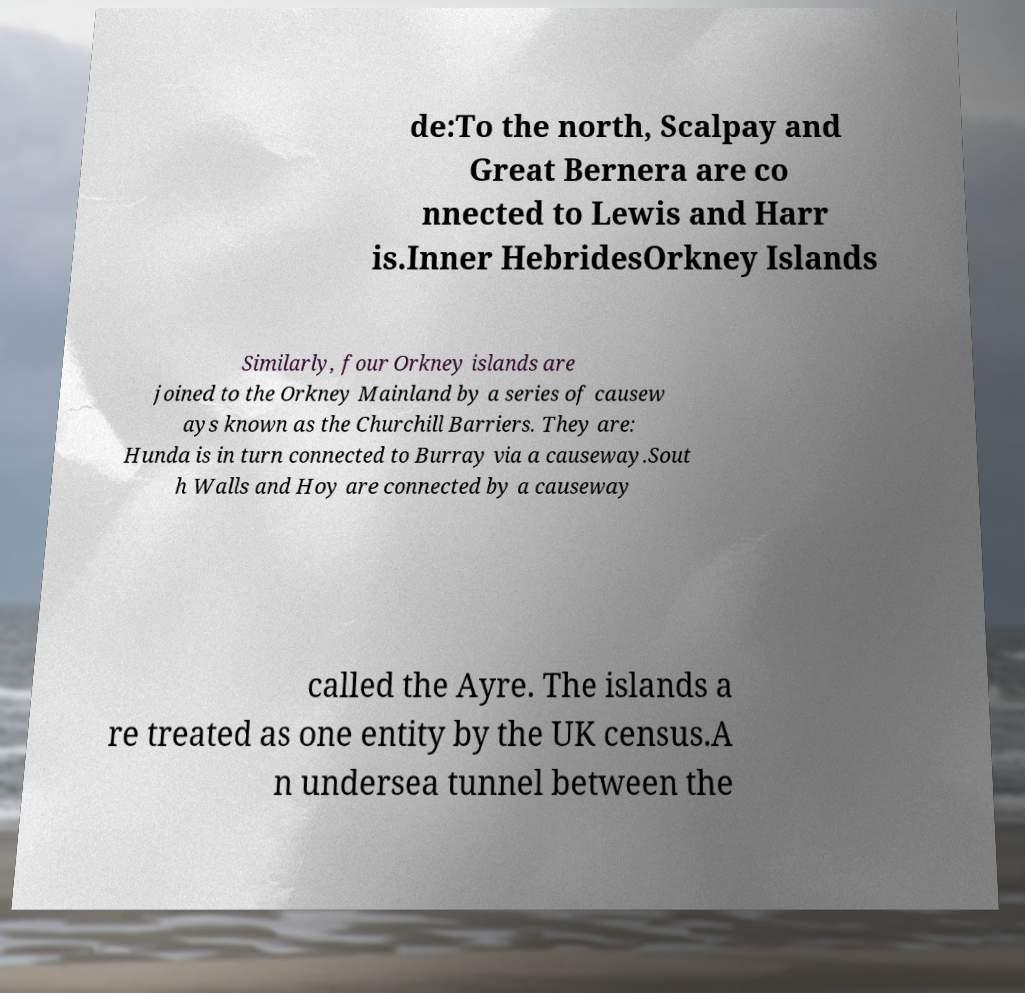Could you assist in decoding the text presented in this image and type it out clearly? de:To the north, Scalpay and Great Bernera are co nnected to Lewis and Harr is.Inner HebridesOrkney Islands Similarly, four Orkney islands are joined to the Orkney Mainland by a series of causew ays known as the Churchill Barriers. They are: Hunda is in turn connected to Burray via a causeway.Sout h Walls and Hoy are connected by a causeway called the Ayre. The islands a re treated as one entity by the UK census.A n undersea tunnel between the 